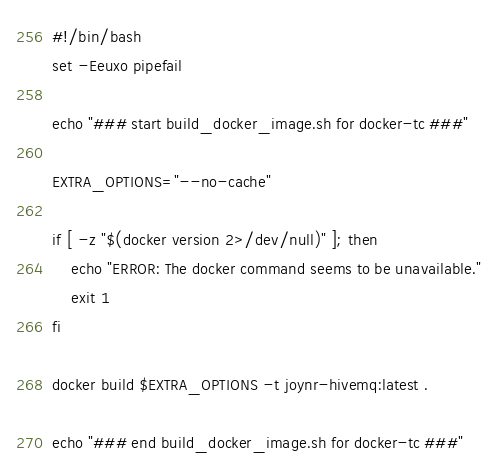<code> <loc_0><loc_0><loc_500><loc_500><_Bash_>#!/bin/bash
set -Eeuxo pipefail

echo "### start build_docker_image.sh for docker-tc ###"

EXTRA_OPTIONS="--no-cache"

if [ -z "$(docker version 2>/dev/null)" ]; then
	echo "ERROR: The docker command seems to be unavailable."
	exit 1
fi

docker build $EXTRA_OPTIONS -t joynr-hivemq:latest .

echo "### end build_docker_image.sh for docker-tc ###"
</code> 